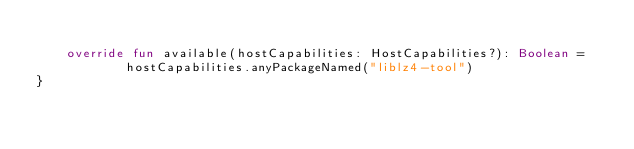Convert code to text. <code><loc_0><loc_0><loc_500><loc_500><_Kotlin_>
	override fun available(hostCapabilities: HostCapabilities?): Boolean =
			hostCapabilities.anyPackageNamed("liblz4-tool")
}</code> 